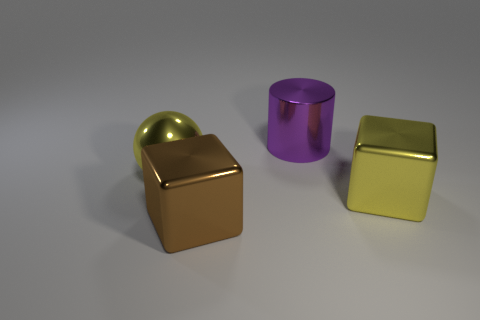There is a object that is the same color as the big shiny ball; what size is it?
Provide a succinct answer. Large. What shape is the yellow shiny object to the left of the purple shiny cylinder?
Offer a very short reply. Sphere. There is a big metal ball that is left of the metallic thing behind the large yellow ball; how many yellow shiny cubes are in front of it?
Ensure brevity in your answer.  1. What is the size of the yellow metal object that is to the right of the big shiny thing to the left of the brown thing?
Your answer should be compact. Large. What number of green cylinders are the same material as the brown cube?
Your response must be concise. 0. Are any purple metal things visible?
Offer a terse response. Yes. What number of big blocks have the same color as the cylinder?
Give a very brief answer. 0. What number of cylinders are small yellow matte objects or purple things?
Your response must be concise. 1. What shape is the large metallic thing that is both in front of the metal ball and left of the large yellow shiny cube?
Give a very brief answer. Cube. Is there a thing of the same size as the shiny cylinder?
Make the answer very short. Yes. 